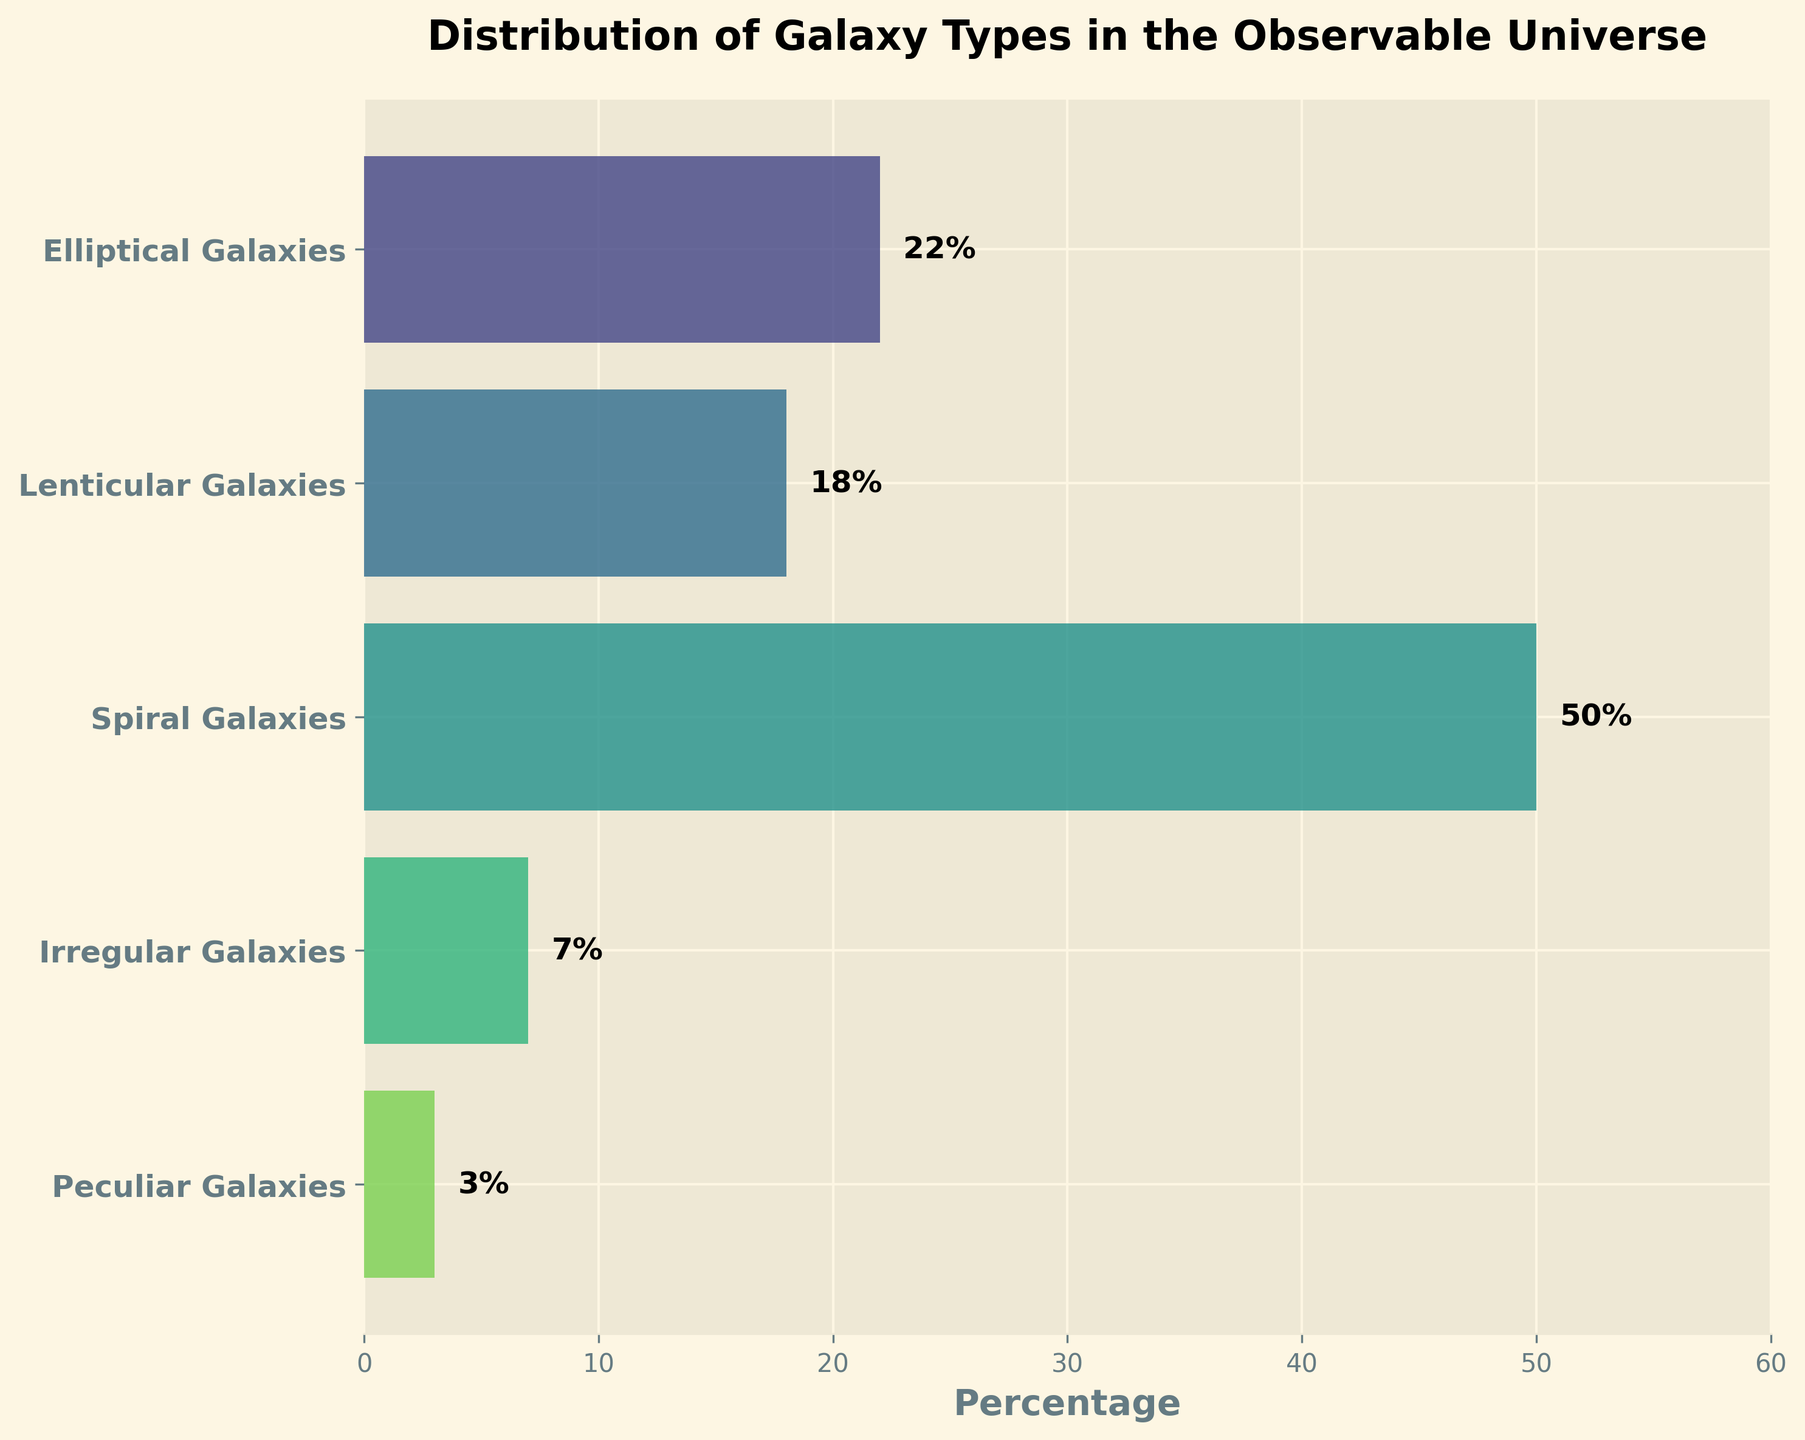what is the highest percentage of a galaxy type in the observable universe? The funnel chart shows various galaxy types and their distribution percentages. To find the highest percentage, we identify the longest bar in the chart. The bar representing "Spiral Galaxies" extends the furthest to the right, indicating the highest percentage of 50%.
Answer: 50% What is the title of the chart? The title is usually found at the top of the chart. In this figure, the title is "Distribution of Galaxy Types in the Observable Universe."
Answer: Distribution of Galaxy Types in the Observable Universe How many galaxy types are represented in the chart? The chart includes multiple bars, each representing a different galaxy type. By counting the bars, we can determine the number of galaxy types. There are 5 different bars in the chart.
Answer: 5 What is the combined percentage of elliptical and lenticular galaxies? To find the combined percentage, we add the individual percentages of "Elliptical Galaxies" (22%) and "Lenticular Galaxies" (18%). The calculation is 22% + 18%.
Answer: 40% Which galaxy type has the smallest percentage, and what is the value? The smallest percentage can be identified by finding the shortest bar in the chart. The bar for "Peculiar Galaxies" is the shortest, with a percentage value of 3%.
Answer: Peculiar Galaxies, 3% What is the difference in percentage between spiral and irregular galaxies? To find the difference, we subtract the smaller percentage from the larger one. The percentage for "Spiral Galaxies" is 50%, and for "Irregular Galaxies," it is 7%. The calculation is 50% - 7%.
Answer: 43% What percentage of galaxies are neither elliptical nor spiral? To determine this, we subtract the combined percentage of "Elliptical Galaxies" and "Spiral Galaxies" from 100%. The combined percentage is 22% + 50% = 72%. The remaining percentage is 100% - 72%.
Answer: 28% Which color scheme is used in the chart? The chart uses a specific color palette to visually differentiate between galaxy types. According to the provided code, a color scheme from the 'viridis' colormap is used, which varies from green to blue.
Answer: viridis colormap What is the percentage difference between lenticular and peculiar galaxies? To find the difference, subtract the smaller percentage from the larger one. The percentage for "Lenticular Galaxies" is 18%, and for "Peculiar Galaxies," it is 3%. The calculation is 18% - 3%.
Answer: 15% What is the total percentage represented by all galaxy types? The sum of all individual percentages will give the total percentage. By adding 22% (Elliptical) + 18% (Lenticular) + 50% (Spiral) + 7% (Irregular) + 3% (Peculiar), the total is 100%.
Answer: 100% 